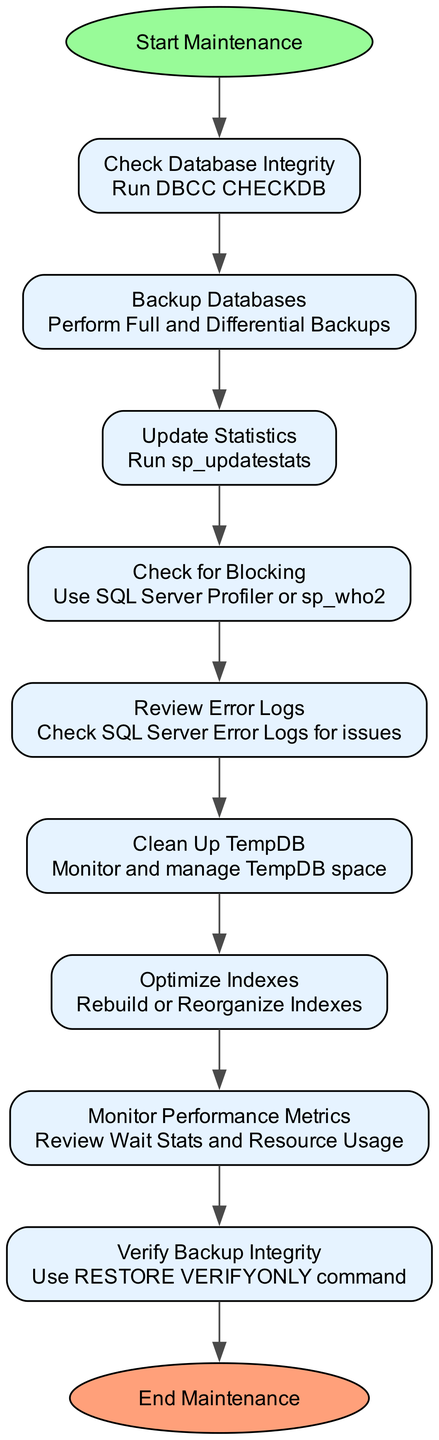What is the first task in the maintenance routine? The diagram begins with a start node that connects to the first task, which is "Check Database Integrity" as indicated by its position.
Answer: Check Database Integrity How many tasks are included in the diagram? By counting the tasks listed in the diagram from "Check Database Integrity" to "Verify Backup Integrity," a total of nine nodes/tasks are present.
Answer: Nine What action is associated with the "Review Error Logs" task? The diagram specifies the action associated with "Review Error Logs," which is to "Check SQL Server Error Logs for issues," shown directly in the respective node.
Answer: Check SQL Server Error Logs for issues What task follows "Clean Up TempDB"? Following the flow from the diagram, the task that comes after "Clean Up TempDB" is "Optimize Indexes," which is the subsequent node in the sequence.
Answer: Optimize Indexes What is the last task before ending maintenance? The diagram indicates that "Verify Backup Integrity" is the final task before reaching the end node, as it is the last task listed in the flow.
Answer: Verify Backup Integrity How does "Update Statistics" relate to "Backup Databases" in the flow? "Update Statistics" comes after "Backup Databases" in the sequence of tasks, creating a direct flow from one to the other in the diagram.
Answer: Sequentially connected What types of actions are performed during maintenance? Analyzing the diagram, the actions involve tasks like backups, integrity checks, log reviews, performance metrics monitoring, and index optimization, indicating a comprehensive maintenance protocol.
Answer: Diverse maintenance actions What is the start node labeled as? The diagram clearly labels the start node as "Start Maintenance," which is the entry point into the maintenance flow chart.
Answer: Start Maintenance What command is used to verify backup integrity? The action for verifying backup integrity in the diagram is stated as using the "RESTORE VERIFYONLY command," which is noted in the corresponding node.
Answer: RESTORE VERIFYONLY command 